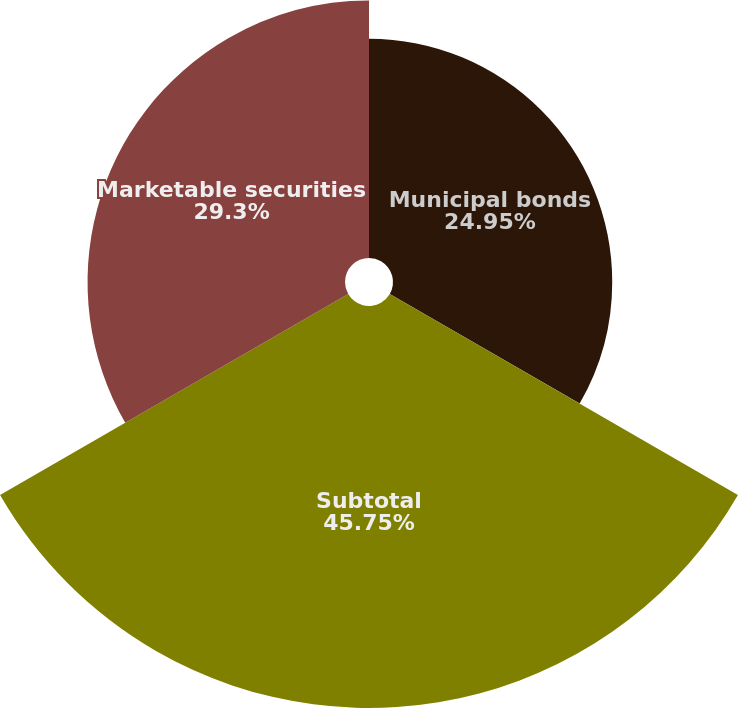Convert chart to OTSL. <chart><loc_0><loc_0><loc_500><loc_500><pie_chart><fcel>Municipal bonds<fcel>Subtotal<fcel>Marketable securities<nl><fcel>24.95%<fcel>45.75%<fcel>29.3%<nl></chart> 